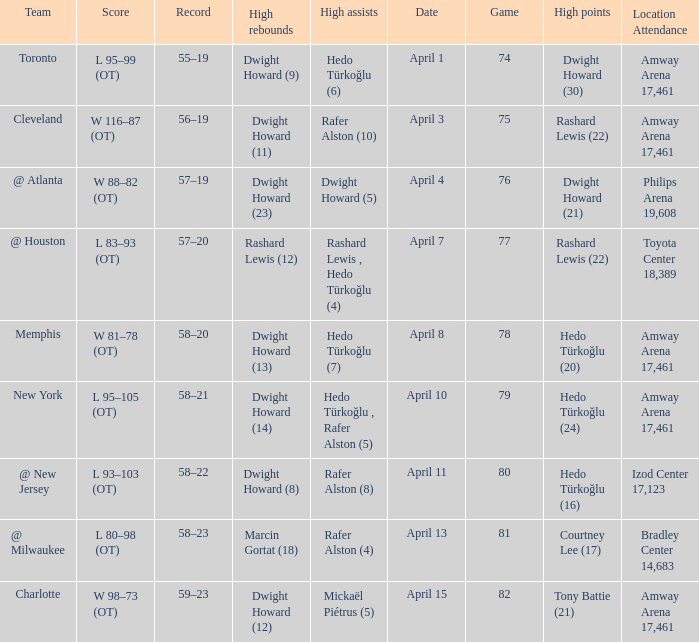What is the highest rebounds for game 81? Marcin Gortat (18). 